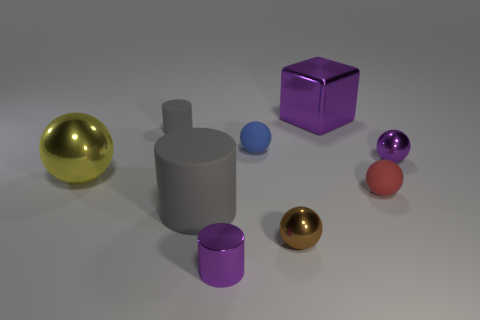How does the lighting in the image affect the appearance of the objects? The lighting creates soft shadows and subtle reflections, enhancing the three-dimensionality of the objects. The metallic spheres reflect more light, highlighting their shiny texture, whereas the other objects have softer, diffused reflections. 